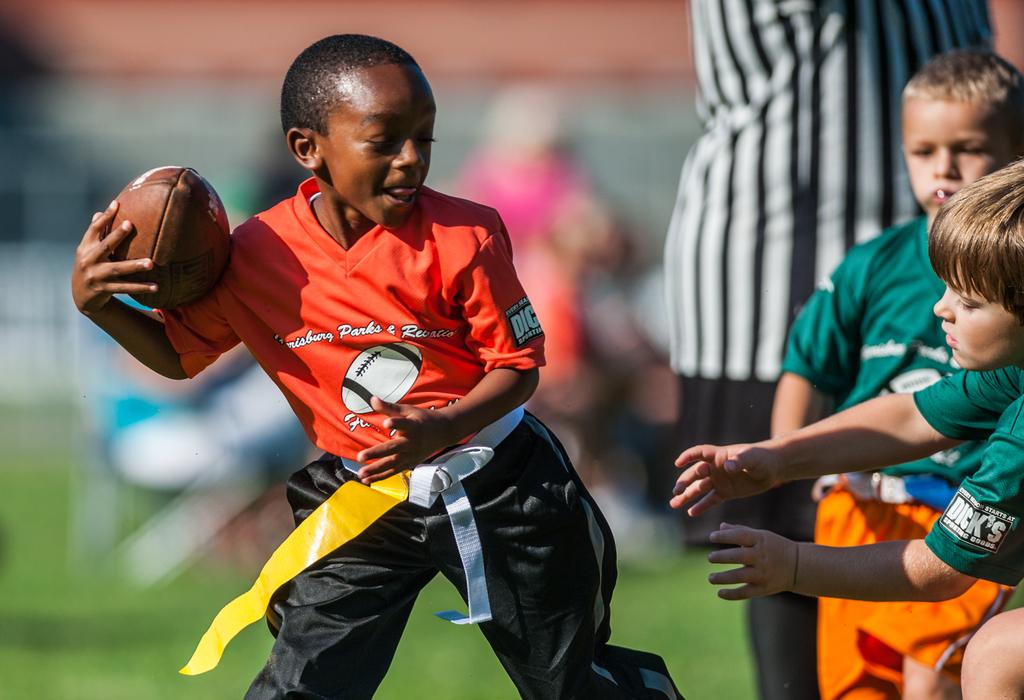What activity are the children engaged in within the image? The children are playing a game in the image. Can you describe the clothing of one of the children? A boy is wearing red in the image. What object is the boy holding in his hand? The boy is holding a ball in his hand. What type of steel is being used to construct the bike in the image? There is no bike present in the image, so it is not possible to determine the type of steel being used. 